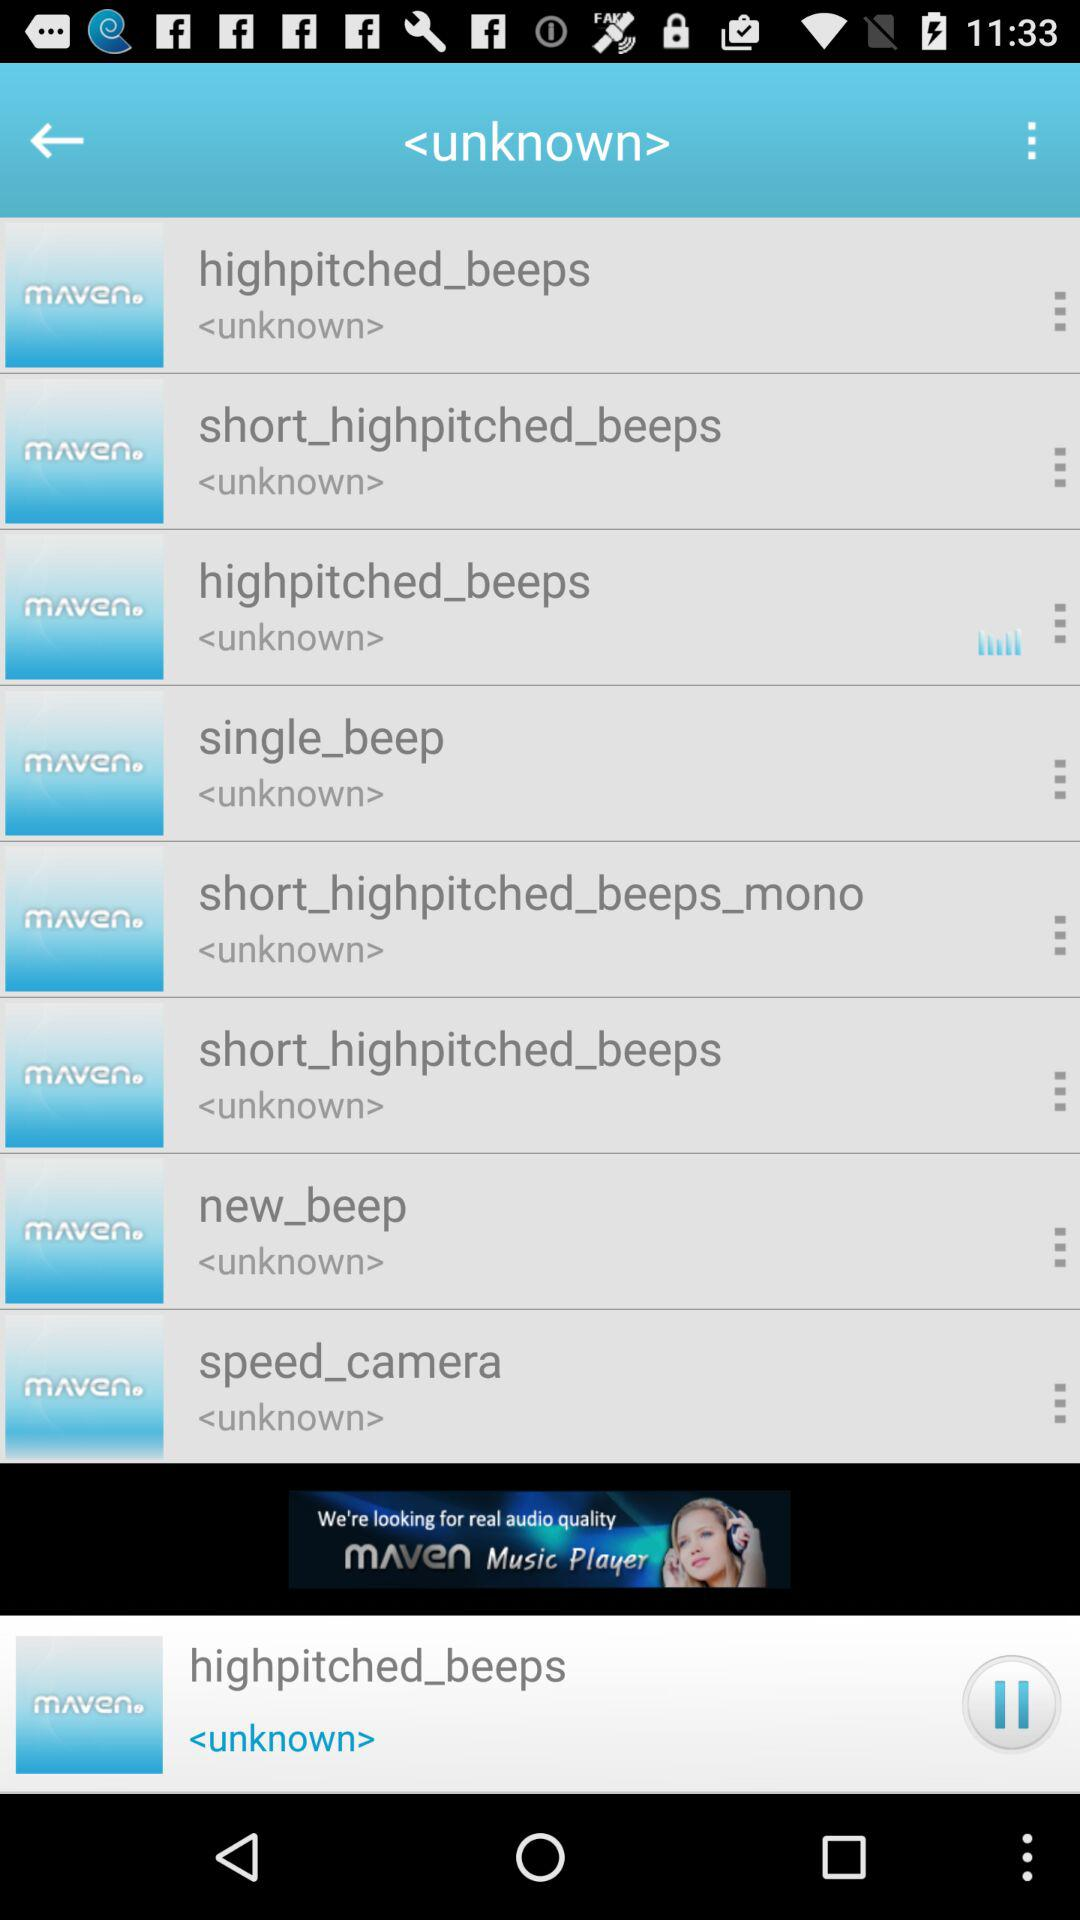Who's the artist of the "highpitched_beeps"? The artist of the "highpitched_beeps" is unknown. 